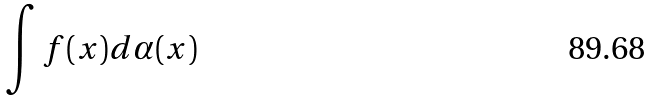<formula> <loc_0><loc_0><loc_500><loc_500>\int f ( x ) d \alpha ( x )</formula> 